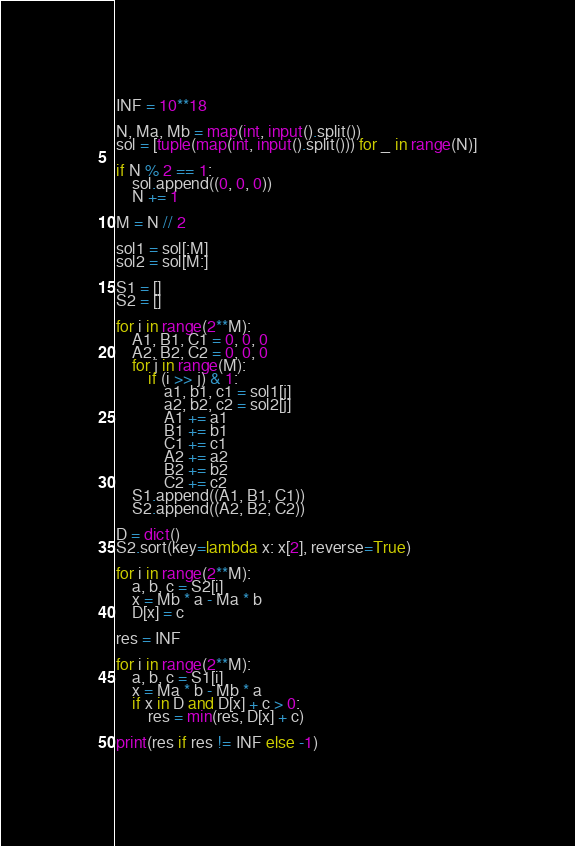<code> <loc_0><loc_0><loc_500><loc_500><_Python_>INF = 10**18

N, Ma, Mb = map(int, input().split())
sol = [tuple(map(int, input().split())) for _ in range(N)]

if N % 2 == 1:
    sol.append((0, 0, 0))
    N += 1

M = N // 2

sol1 = sol[:M]
sol2 = sol[M:]

S1 = []
S2 = []

for i in range(2**M):
    A1, B1, C1 = 0, 0, 0
    A2, B2, C2 = 0, 0, 0
    for j in range(M):
        if (i >> j) & 1:
            a1, b1, c1 = sol1[j]
            a2, b2, c2 = sol2[j]
            A1 += a1
            B1 += b1
            C1 += c1
            A2 += a2
            B2 += b2
            C2 += c2
    S1.append((A1, B1, C1))
    S2.append((A2, B2, C2))

D = dict()
S2.sort(key=lambda x: x[2], reverse=True)

for i in range(2**M):
    a, b, c = S2[i]
    x = Mb * a - Ma * b
    D[x] = c

res = INF

for i in range(2**M):
    a, b, c = S1[i]
    x = Ma * b - Mb * a
    if x in D and D[x] + c > 0:
        res = min(res, D[x] + c)

print(res if res != INF else -1)</code> 